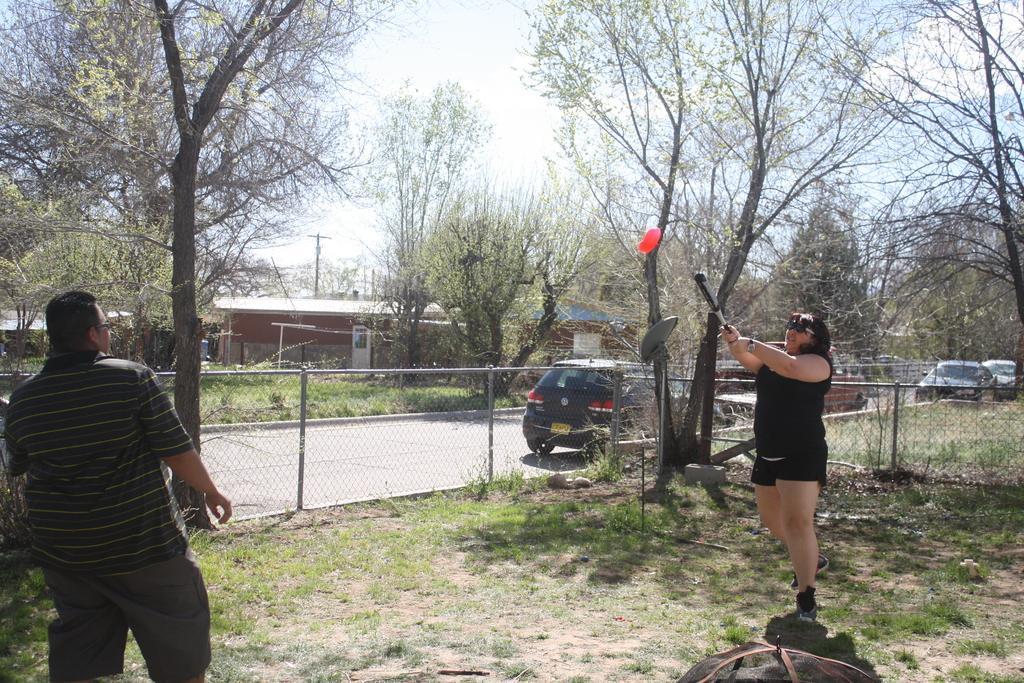Please provide a concise description of this image. In this picture we can see two persons standing on the ground,she is holding a bat,here we can see a fence,vehicles on the road and buildings. In the background we can see trees,sky. 